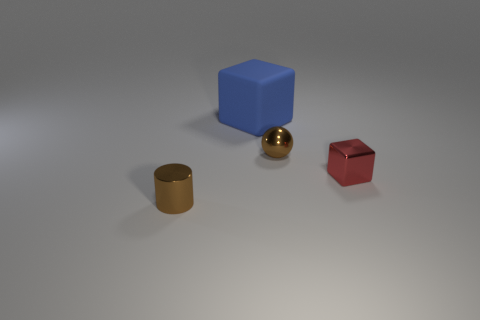Is there another metal block of the same color as the large block?
Keep it short and to the point. No. Are there any matte balls?
Ensure brevity in your answer.  No. There is a brown object right of the large blue rubber block; what is its shape?
Keep it short and to the point. Sphere. How many objects are both right of the large rubber thing and in front of the tiny brown metallic sphere?
Keep it short and to the point. 1. How many other things are the same size as the red thing?
Give a very brief answer. 2. Is the shape of the brown object that is in front of the tiny red metallic thing the same as the brown metallic object that is behind the metal block?
Offer a very short reply. No. How many objects are either small blue matte cylinders or tiny brown things that are right of the tiny shiny cylinder?
Offer a terse response. 1. There is a thing that is both left of the brown sphere and in front of the small brown shiny sphere; what is its material?
Offer a terse response. Metal. Is there any other thing that has the same shape as the red metal object?
Your answer should be very brief. Yes. What is the color of the cylinder that is the same material as the tiny brown sphere?
Your answer should be compact. Brown. 